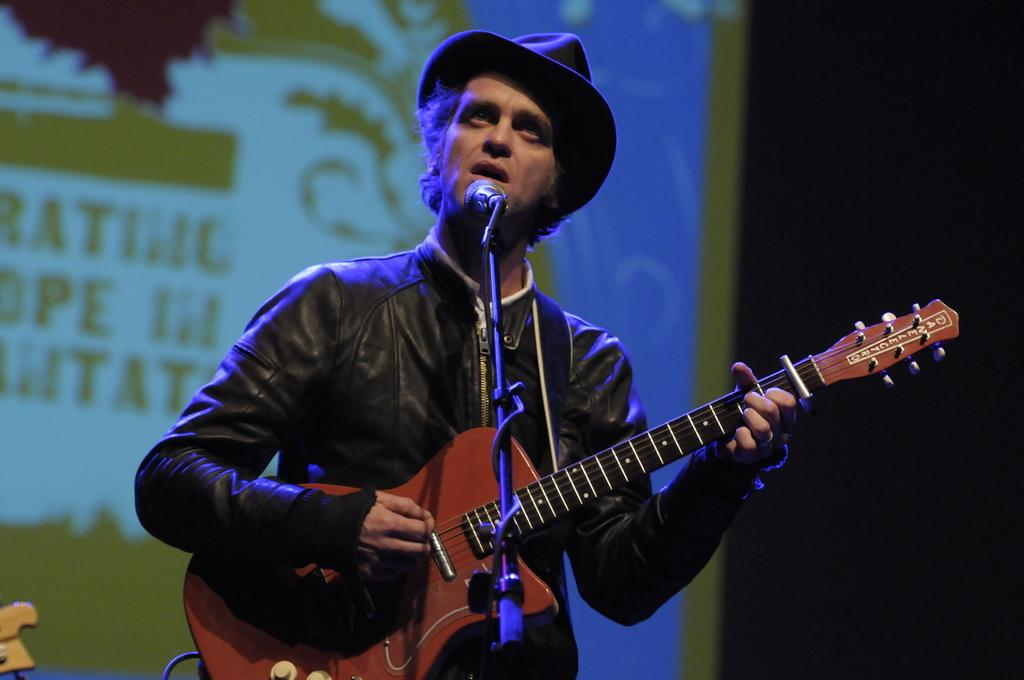What is the man in the image doing? The man is holding a guitar and singing into a microphone. What object is the man holding in his hand? The man is holding a guitar. What accessory is the man wearing on his head? The man is wearing a hat. What additional feature can be seen in the image? There is a banner visible in the image. What type of chin can be seen on the clam in the image? There is no clam or chin present in the image; it features a man holding a guitar and singing into a microphone. 